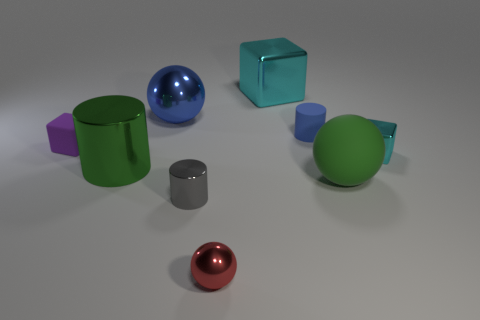There is a purple thing; is its size the same as the cube that is behind the blue sphere?
Your answer should be very brief. No. There is a big object that is both on the right side of the large blue shiny sphere and behind the tiny blue cylinder; what is its shape?
Offer a very short reply. Cube. How many large objects are spheres or red metal things?
Make the answer very short. 2. Are there the same number of matte balls behind the large shiny ball and purple rubber blocks that are in front of the tiny rubber block?
Your answer should be very brief. Yes. How many other objects are the same color as the large cylinder?
Make the answer very short. 1. Are there an equal number of green balls on the left side of the tiny purple thing and green shiny objects?
Offer a very short reply. No. Do the matte block and the green metallic thing have the same size?
Make the answer very short. No. What material is the object that is left of the gray cylinder and right of the green cylinder?
Give a very brief answer. Metal. How many big cyan objects are the same shape as the tiny gray shiny object?
Your response must be concise. 0. What is the green sphere in front of the small cyan thing made of?
Offer a very short reply. Rubber. 